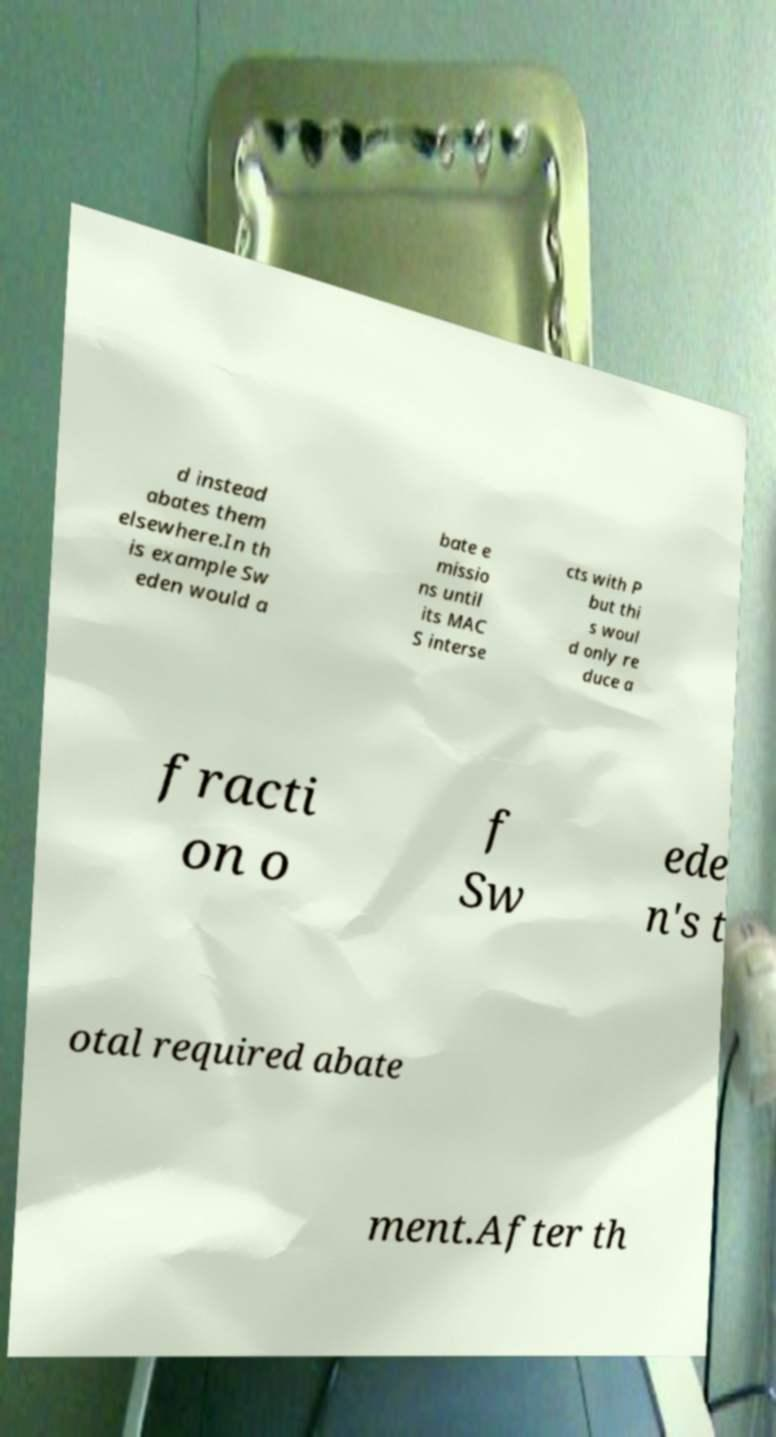Could you assist in decoding the text presented in this image and type it out clearly? d instead abates them elsewhere.In th is example Sw eden would a bate e missio ns until its MAC S interse cts with P but thi s woul d only re duce a fracti on o f Sw ede n's t otal required abate ment.After th 